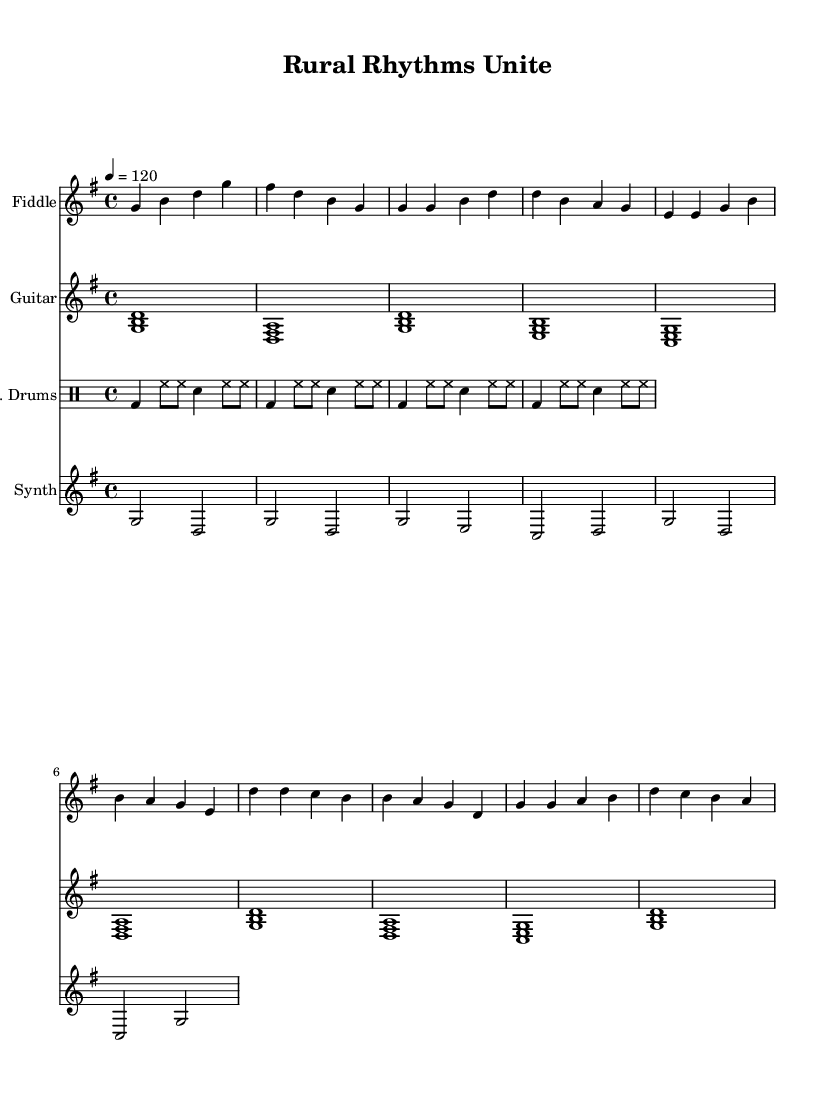What is the key signature of this music? The key signature is G major, which has one sharp (F#). This is determined by looking at the beginning of the staff, which indicates the pitch relationships for the notes throughout the score.
Answer: G major What is the time signature of this music? The time signature is 4/4, which is indicated at the beginning of the sheet music. It tells us that there are four beats in each measure and the quarter note receives one beat.
Answer: 4/4 What is the tempo marking for this piece? The tempo marking is quarter note equals 120 beats per minute. This is specified in the tempo indication at the start of the score, setting the speed for the performance.
Answer: 120 How many measures does the fiddle part contain? The fiddle part contains 8 measures. By counting the vertical lines (bar lines) in the fiddle staff, we see that there are eight segments defined within the music notation.
Answer: 8 What type of drums are used in this score? The score includes electronic drums, as indicated by the instrument name on the drum staff. This suggests an integration of modern technology into the traditional dance genre.
Answer: Electronic drums Which instruments are involved in creating a fusion of traditional and modern sounds? The instruments involved are fiddle, guitar, electronic drums, and synth. This combination reflects the blending of folk traditions with contemporary influences, aiming to appeal to diverse rural patrons.
Answer: Fiddle, guitar, electronic drums, synth What is the rhythmic pattern of the drum part in the first measure? The rhythmic pattern in the first measure consists of a bass drum on the first beat, followed by hi-hat notes on the subsequent eighth notes, and a snare drum on the third beat. This layered approach establishes a driving rhythm typical of dance music.
Answer: Bass and hi-hat 